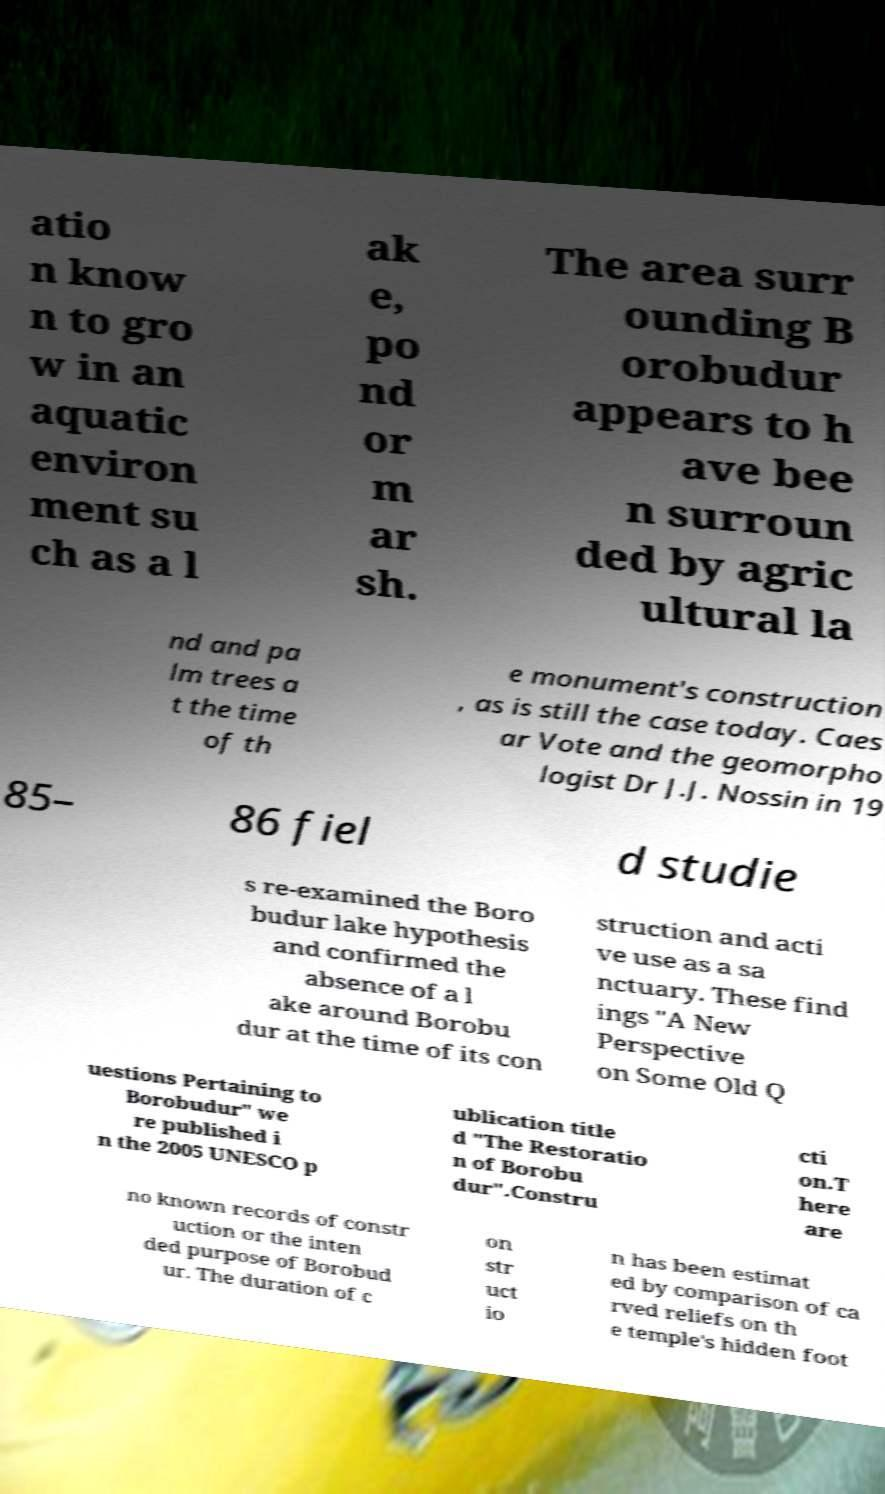Could you extract and type out the text from this image? atio n know n to gro w in an aquatic environ ment su ch as a l ak e, po nd or m ar sh. The area surr ounding B orobudur appears to h ave bee n surroun ded by agric ultural la nd and pa lm trees a t the time of th e monument's construction , as is still the case today. Caes ar Vote and the geomorpho logist Dr J.J. Nossin in 19 85– 86 fiel d studie s re-examined the Boro budur lake hypothesis and confirmed the absence of a l ake around Borobu dur at the time of its con struction and acti ve use as a sa nctuary. These find ings "A New Perspective on Some Old Q uestions Pertaining to Borobudur" we re published i n the 2005 UNESCO p ublication title d "The Restoratio n of Borobu dur".Constru cti on.T here are no known records of constr uction or the inten ded purpose of Borobud ur. The duration of c on str uct io n has been estimat ed by comparison of ca rved reliefs on th e temple's hidden foot 